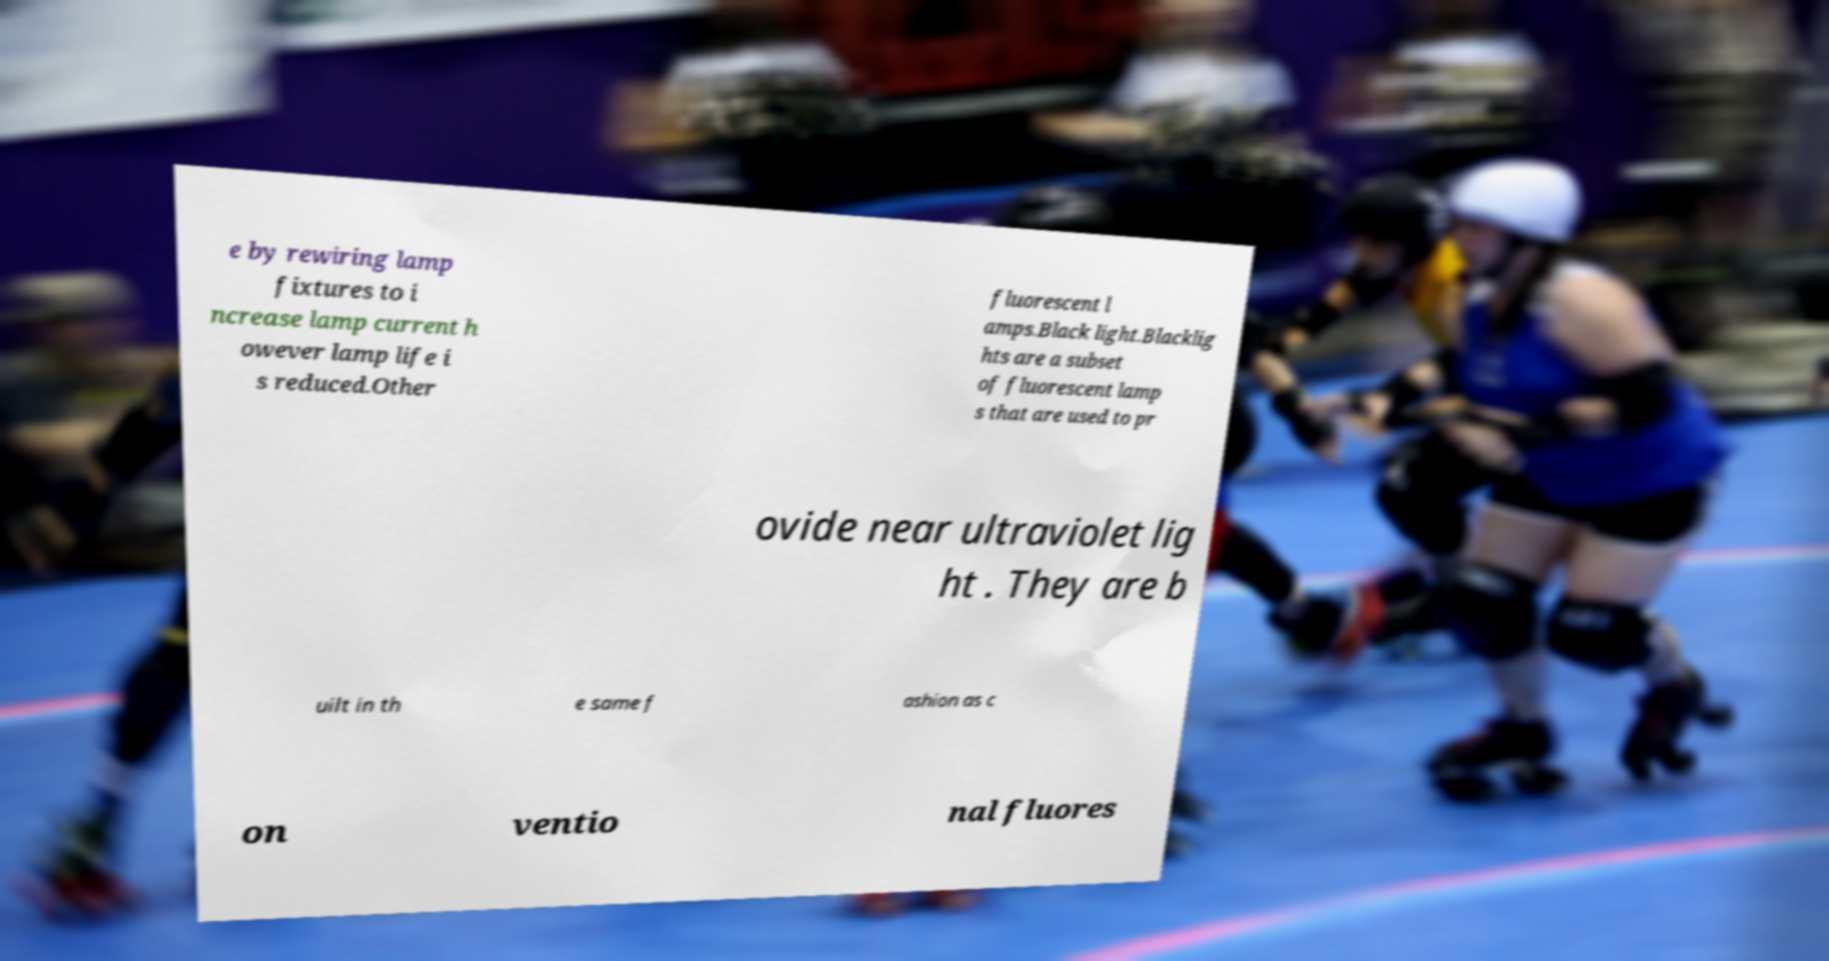Can you accurately transcribe the text from the provided image for me? e by rewiring lamp fixtures to i ncrease lamp current h owever lamp life i s reduced.Other fluorescent l amps.Black light.Blacklig hts are a subset of fluorescent lamp s that are used to pr ovide near ultraviolet lig ht . They are b uilt in th e same f ashion as c on ventio nal fluores 